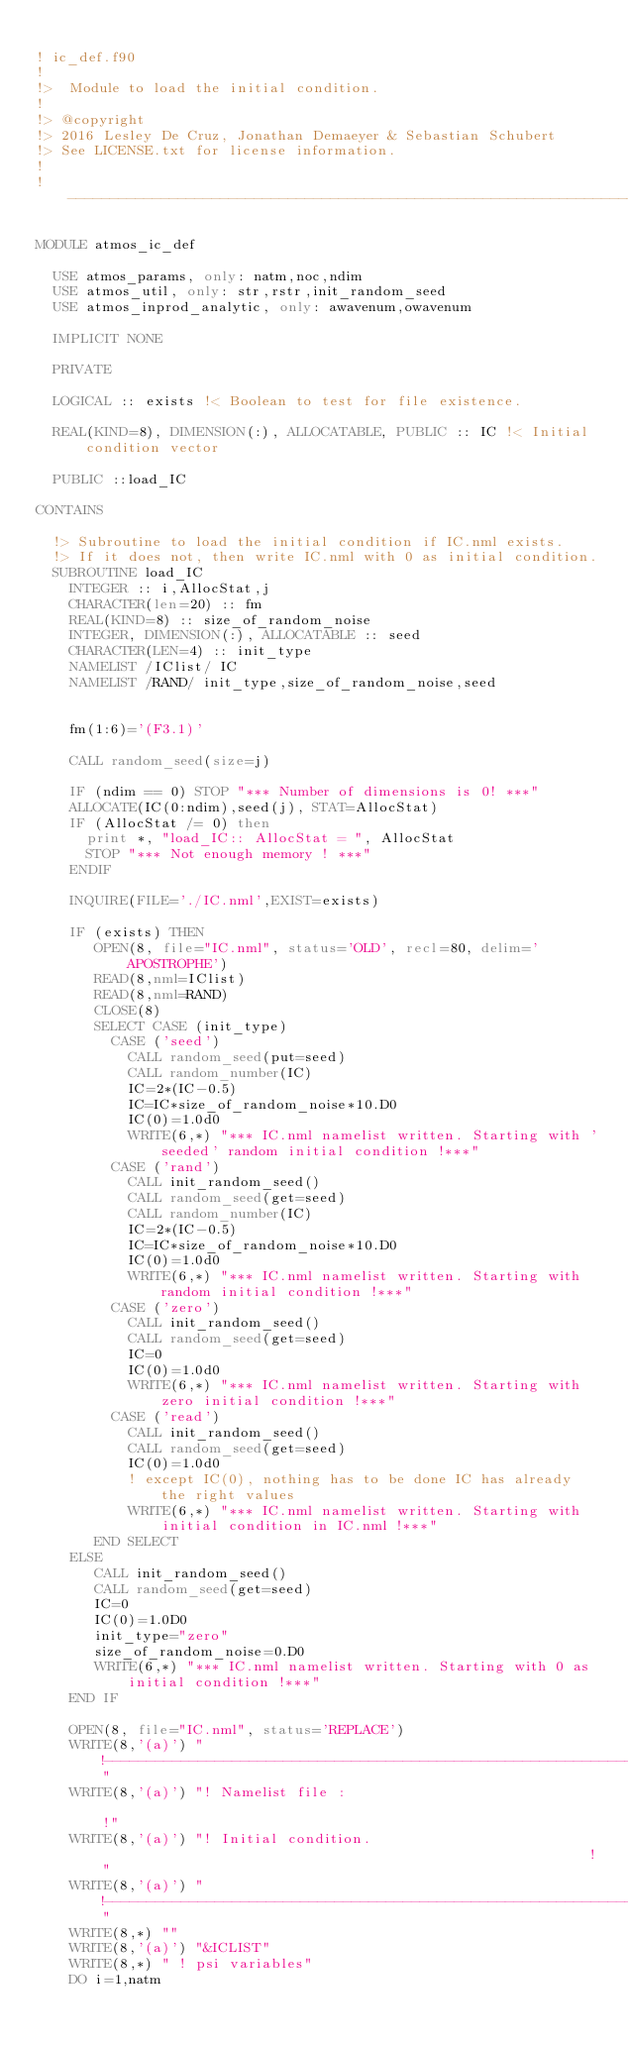Convert code to text. <code><loc_0><loc_0><loc_500><loc_500><_FORTRAN_>
! ic_def.f90
!
!>  Module to load the initial condition.
!
!> @copyright                                                               
!> 2016 Lesley De Cruz, Jonathan Demaeyer & Sebastian Schubert
!> See LICENSE.txt for license information.                                  
!
!---------------------------------------------------------------------------!

MODULE atmos_ic_def

  USE atmos_params, only: natm,noc,ndim
  USE atmos_util, only: str,rstr,init_random_seed
  USE atmos_inprod_analytic, only: awavenum,owavenum

  IMPLICIT NONE

  PRIVATE

  LOGICAL :: exists !< Boolean to test for file existence.
  
  REAL(KIND=8), DIMENSION(:), ALLOCATABLE, PUBLIC :: IC !< Initial condition vector

  PUBLIC ::load_IC

CONTAINS

  !> Subroutine to load the initial condition if IC.nml exists.
  !> If it does not, then write IC.nml with 0 as initial condition.
  SUBROUTINE load_IC
    INTEGER :: i,AllocStat,j
    CHARACTER(len=20) :: fm
    REAL(KIND=8) :: size_of_random_noise
    INTEGER, DIMENSION(:), ALLOCATABLE :: seed
    CHARACTER(LEN=4) :: init_type 
    NAMELIST /IClist/ IC
    NAMELIST /RAND/ init_type,size_of_random_noise,seed


    fm(1:6)='(F3.1)'

    CALL random_seed(size=j)
   
    IF (ndim == 0) STOP "*** Number of dimensions is 0! ***"
    ALLOCATE(IC(0:ndim),seed(j), STAT=AllocStat)
    IF (AllocStat /= 0) then
      print *, "load_IC:: AllocStat = ", AllocStat
      STOP "*** Not enough memory ! ***"
    ENDIF

    INQUIRE(FILE='./IC.nml',EXIST=exists)

    IF (exists) THEN
       OPEN(8, file="IC.nml", status='OLD', recl=80, delim='APOSTROPHE')
       READ(8,nml=IClist)
       READ(8,nml=RAND)
       CLOSE(8)
       SELECT CASE (init_type)
         CASE ('seed')
           CALL random_seed(put=seed)
           CALL random_number(IC)
           IC=2*(IC-0.5)
           IC=IC*size_of_random_noise*10.D0
           IC(0)=1.0d0
           WRITE(6,*) "*** IC.nml namelist written. Starting with 'seeded' random initial condition !***"
         CASE ('rand')
           CALL init_random_seed()
           CALL random_seed(get=seed)
           CALL random_number(IC)
           IC=2*(IC-0.5)
           IC=IC*size_of_random_noise*10.D0
           IC(0)=1.0d0
           WRITE(6,*) "*** IC.nml namelist written. Starting with random initial condition !***"
         CASE ('zero')
           CALL init_random_seed()
           CALL random_seed(get=seed)
           IC=0
           IC(0)=1.0d0
           WRITE(6,*) "*** IC.nml namelist written. Starting with zero initial condition !***"
         CASE ('read')
           CALL init_random_seed()
           CALL random_seed(get=seed)
           IC(0)=1.0d0
           ! except IC(0), nothing has to be done IC has already the right values
           WRITE(6,*) "*** IC.nml namelist written. Starting with initial condition in IC.nml !***"
       END SELECT
    ELSE
       CALL init_random_seed()
       CALL random_seed(get=seed)
       IC=0
       IC(0)=1.0D0
       init_type="zero"
       size_of_random_noise=0.D0
       WRITE(6,*) "*** IC.nml namelist written. Starting with 0 as initial condition !***"
    END IF

    OPEN(8, file="IC.nml", status='REPLACE')
    WRITE(8,'(a)') "!------------------------------------------------------------------------------!"
    WRITE(8,'(a)') "! Namelist file :                                                              !"
    WRITE(8,'(a)') "! Initial condition.                                                           !"
    WRITE(8,'(a)') "!------------------------------------------------------------------------------!"
    WRITE(8,*) ""
    WRITE(8,'(a)') "&ICLIST"
    WRITE(8,*) " ! psi variables"
    DO i=1,natm</code> 